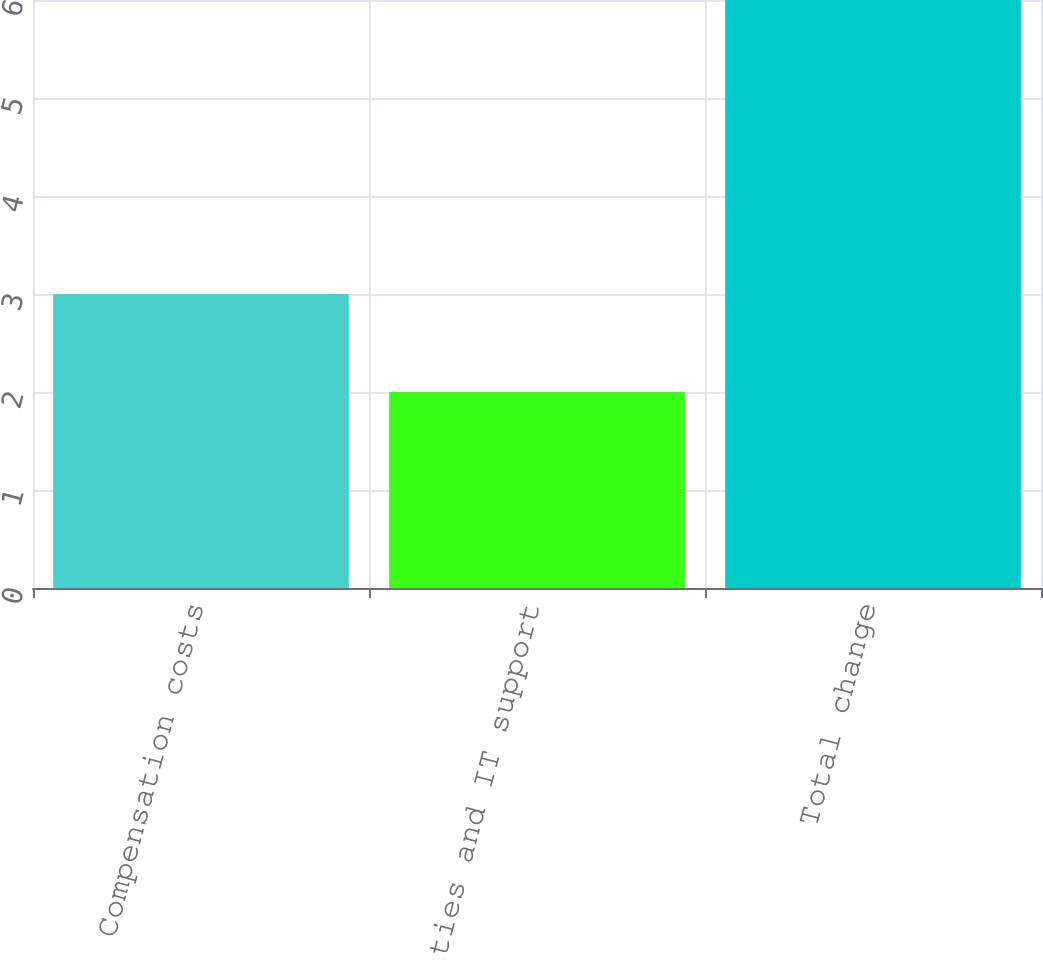Convert chart. <chart><loc_0><loc_0><loc_500><loc_500><bar_chart><fcel>Compensation costs<fcel>Facilities and IT support<fcel>Total change<nl><fcel>3<fcel>2<fcel>6<nl></chart> 